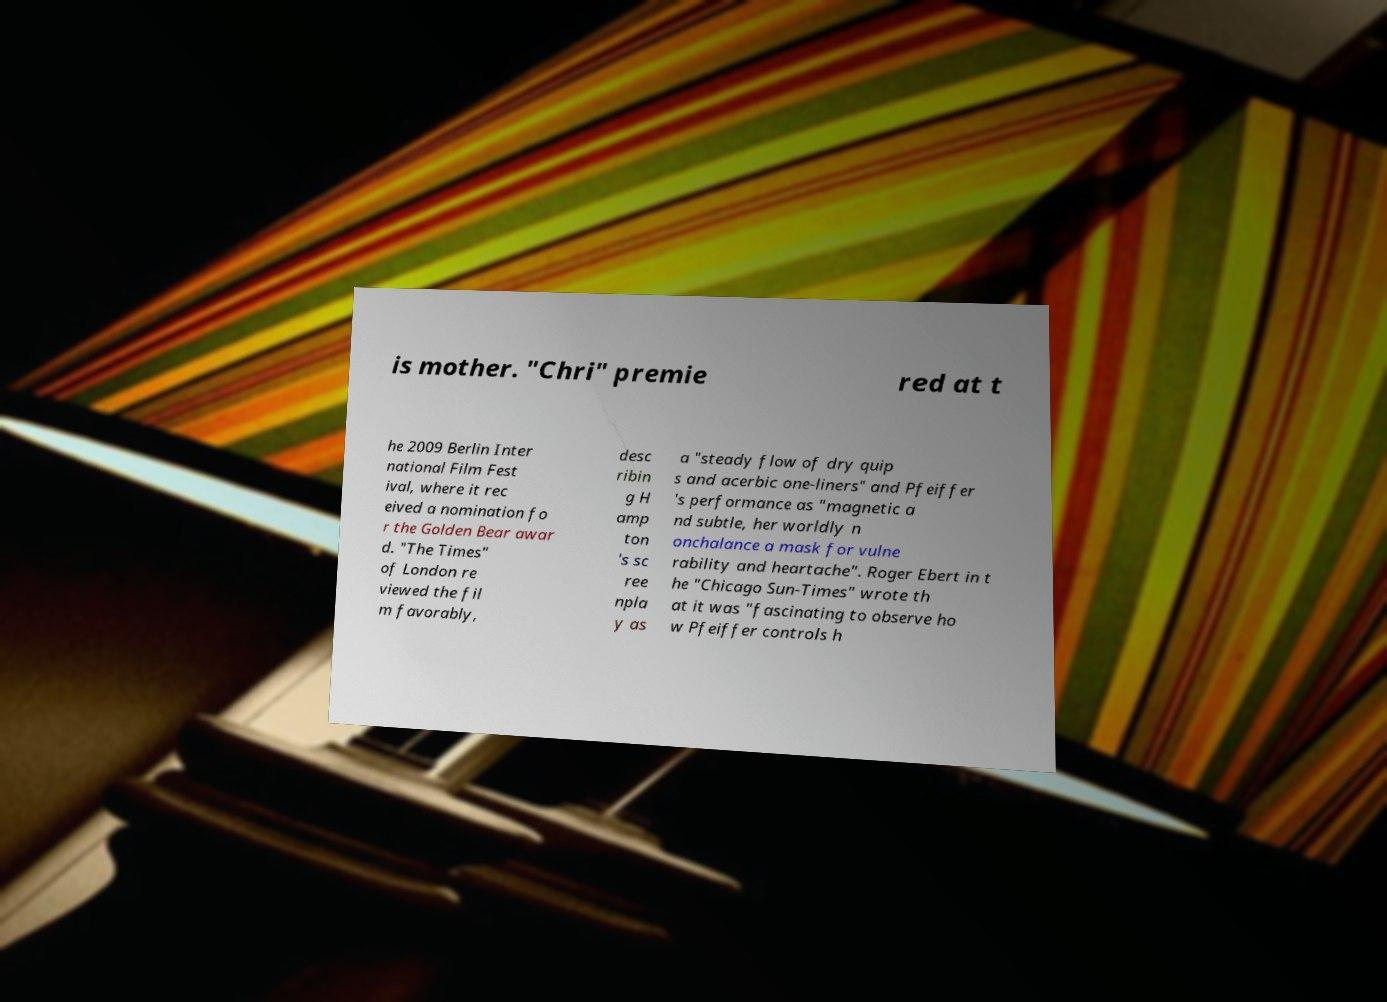Please identify and transcribe the text found in this image. is mother. "Chri" premie red at t he 2009 Berlin Inter national Film Fest ival, where it rec eived a nomination fo r the Golden Bear awar d. "The Times" of London re viewed the fil m favorably, desc ribin g H amp ton 's sc ree npla y as a "steady flow of dry quip s and acerbic one-liners" and Pfeiffer 's performance as "magnetic a nd subtle, her worldly n onchalance a mask for vulne rability and heartache". Roger Ebert in t he "Chicago Sun-Times" wrote th at it was "fascinating to observe ho w Pfeiffer controls h 